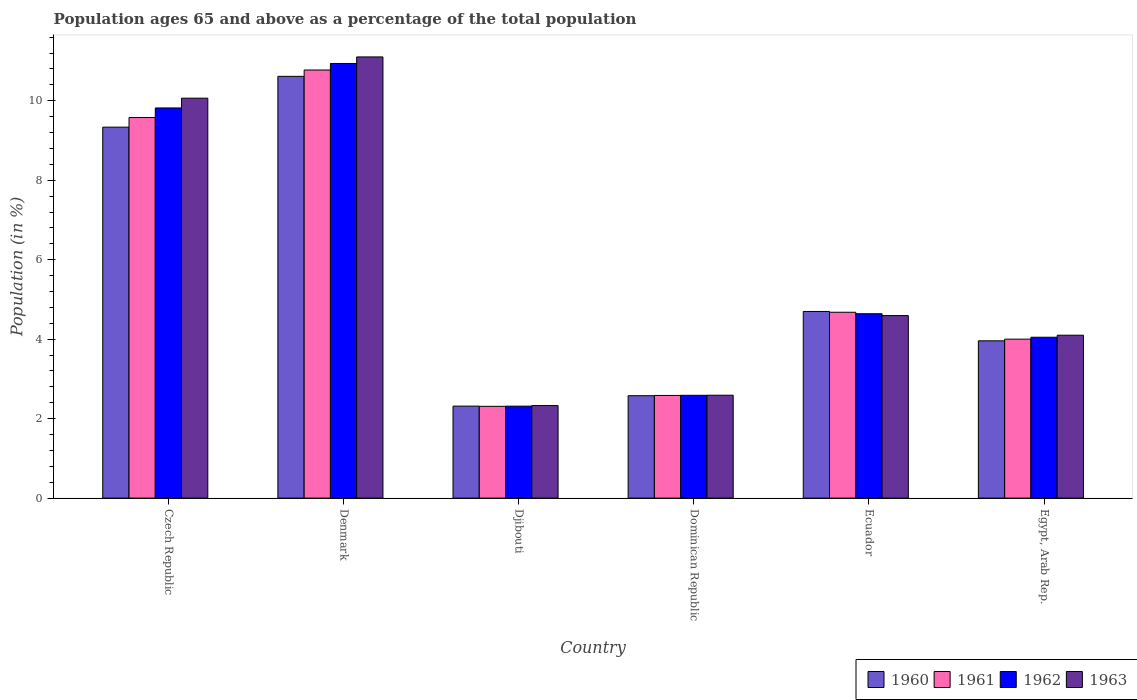Are the number of bars on each tick of the X-axis equal?
Your answer should be compact. Yes. How many bars are there on the 6th tick from the left?
Provide a succinct answer. 4. What is the label of the 5th group of bars from the left?
Provide a short and direct response. Ecuador. In how many cases, is the number of bars for a given country not equal to the number of legend labels?
Provide a short and direct response. 0. What is the percentage of the population ages 65 and above in 1963 in Egypt, Arab Rep.?
Provide a short and direct response. 4.1. Across all countries, what is the maximum percentage of the population ages 65 and above in 1963?
Give a very brief answer. 11.1. Across all countries, what is the minimum percentage of the population ages 65 and above in 1963?
Provide a succinct answer. 2.33. In which country was the percentage of the population ages 65 and above in 1963 minimum?
Offer a very short reply. Djibouti. What is the total percentage of the population ages 65 and above in 1963 in the graph?
Provide a short and direct response. 34.78. What is the difference between the percentage of the population ages 65 and above in 1961 in Denmark and that in Djibouti?
Your answer should be compact. 8.46. What is the difference between the percentage of the population ages 65 and above in 1961 in Dominican Republic and the percentage of the population ages 65 and above in 1962 in Denmark?
Your answer should be compact. -8.36. What is the average percentage of the population ages 65 and above in 1963 per country?
Your answer should be compact. 5.8. What is the difference between the percentage of the population ages 65 and above of/in 1961 and percentage of the population ages 65 and above of/in 1960 in Czech Republic?
Your answer should be very brief. 0.24. In how many countries, is the percentage of the population ages 65 and above in 1962 greater than 6?
Offer a terse response. 2. What is the ratio of the percentage of the population ages 65 and above in 1961 in Czech Republic to that in Egypt, Arab Rep.?
Ensure brevity in your answer.  2.39. Is the difference between the percentage of the population ages 65 and above in 1961 in Denmark and Egypt, Arab Rep. greater than the difference between the percentage of the population ages 65 and above in 1960 in Denmark and Egypt, Arab Rep.?
Your response must be concise. Yes. What is the difference between the highest and the second highest percentage of the population ages 65 and above in 1963?
Offer a terse response. -1.04. What is the difference between the highest and the lowest percentage of the population ages 65 and above in 1961?
Give a very brief answer. 8.46. Is the sum of the percentage of the population ages 65 and above in 1963 in Dominican Republic and Ecuador greater than the maximum percentage of the population ages 65 and above in 1962 across all countries?
Offer a terse response. No. Is it the case that in every country, the sum of the percentage of the population ages 65 and above in 1960 and percentage of the population ages 65 and above in 1963 is greater than the sum of percentage of the population ages 65 and above in 1961 and percentage of the population ages 65 and above in 1962?
Your answer should be very brief. No. Is it the case that in every country, the sum of the percentage of the population ages 65 and above in 1963 and percentage of the population ages 65 and above in 1962 is greater than the percentage of the population ages 65 and above in 1961?
Provide a short and direct response. Yes. How many bars are there?
Your answer should be very brief. 24. Are the values on the major ticks of Y-axis written in scientific E-notation?
Your response must be concise. No. Does the graph contain grids?
Offer a very short reply. No. Where does the legend appear in the graph?
Make the answer very short. Bottom right. What is the title of the graph?
Your response must be concise. Population ages 65 and above as a percentage of the total population. What is the Population (in %) of 1960 in Czech Republic?
Give a very brief answer. 9.34. What is the Population (in %) of 1961 in Czech Republic?
Provide a short and direct response. 9.58. What is the Population (in %) of 1962 in Czech Republic?
Make the answer very short. 9.82. What is the Population (in %) of 1963 in Czech Republic?
Make the answer very short. 10.07. What is the Population (in %) in 1960 in Denmark?
Ensure brevity in your answer.  10.61. What is the Population (in %) of 1961 in Denmark?
Keep it short and to the point. 10.77. What is the Population (in %) in 1962 in Denmark?
Provide a short and direct response. 10.94. What is the Population (in %) of 1963 in Denmark?
Your answer should be very brief. 11.1. What is the Population (in %) of 1960 in Djibouti?
Give a very brief answer. 2.31. What is the Population (in %) of 1961 in Djibouti?
Make the answer very short. 2.31. What is the Population (in %) of 1962 in Djibouti?
Provide a short and direct response. 2.31. What is the Population (in %) in 1963 in Djibouti?
Your response must be concise. 2.33. What is the Population (in %) of 1960 in Dominican Republic?
Offer a terse response. 2.58. What is the Population (in %) in 1961 in Dominican Republic?
Ensure brevity in your answer.  2.58. What is the Population (in %) of 1962 in Dominican Republic?
Provide a short and direct response. 2.59. What is the Population (in %) in 1963 in Dominican Republic?
Ensure brevity in your answer.  2.59. What is the Population (in %) of 1960 in Ecuador?
Provide a succinct answer. 4.7. What is the Population (in %) of 1961 in Ecuador?
Make the answer very short. 4.68. What is the Population (in %) in 1962 in Ecuador?
Keep it short and to the point. 4.64. What is the Population (in %) of 1963 in Ecuador?
Your answer should be compact. 4.59. What is the Population (in %) of 1960 in Egypt, Arab Rep.?
Offer a very short reply. 3.96. What is the Population (in %) of 1961 in Egypt, Arab Rep.?
Your response must be concise. 4. What is the Population (in %) of 1962 in Egypt, Arab Rep.?
Offer a terse response. 4.05. What is the Population (in %) in 1963 in Egypt, Arab Rep.?
Offer a very short reply. 4.1. Across all countries, what is the maximum Population (in %) in 1960?
Offer a terse response. 10.61. Across all countries, what is the maximum Population (in %) in 1961?
Your response must be concise. 10.77. Across all countries, what is the maximum Population (in %) in 1962?
Offer a terse response. 10.94. Across all countries, what is the maximum Population (in %) in 1963?
Your response must be concise. 11.1. Across all countries, what is the minimum Population (in %) of 1960?
Your answer should be very brief. 2.31. Across all countries, what is the minimum Population (in %) of 1961?
Offer a terse response. 2.31. Across all countries, what is the minimum Population (in %) in 1962?
Offer a terse response. 2.31. Across all countries, what is the minimum Population (in %) in 1963?
Give a very brief answer. 2.33. What is the total Population (in %) in 1960 in the graph?
Keep it short and to the point. 33.5. What is the total Population (in %) of 1961 in the graph?
Your response must be concise. 33.92. What is the total Population (in %) in 1962 in the graph?
Keep it short and to the point. 34.35. What is the total Population (in %) in 1963 in the graph?
Your answer should be compact. 34.78. What is the difference between the Population (in %) in 1960 in Czech Republic and that in Denmark?
Your answer should be compact. -1.28. What is the difference between the Population (in %) in 1961 in Czech Republic and that in Denmark?
Offer a terse response. -1.2. What is the difference between the Population (in %) in 1962 in Czech Republic and that in Denmark?
Keep it short and to the point. -1.12. What is the difference between the Population (in %) of 1963 in Czech Republic and that in Denmark?
Give a very brief answer. -1.04. What is the difference between the Population (in %) of 1960 in Czech Republic and that in Djibouti?
Make the answer very short. 7.02. What is the difference between the Population (in %) of 1961 in Czech Republic and that in Djibouti?
Give a very brief answer. 7.27. What is the difference between the Population (in %) in 1962 in Czech Republic and that in Djibouti?
Make the answer very short. 7.51. What is the difference between the Population (in %) of 1963 in Czech Republic and that in Djibouti?
Offer a terse response. 7.74. What is the difference between the Population (in %) of 1960 in Czech Republic and that in Dominican Republic?
Your answer should be very brief. 6.76. What is the difference between the Population (in %) in 1961 in Czech Republic and that in Dominican Republic?
Your answer should be very brief. 7. What is the difference between the Population (in %) in 1962 in Czech Republic and that in Dominican Republic?
Your answer should be compact. 7.23. What is the difference between the Population (in %) in 1963 in Czech Republic and that in Dominican Republic?
Your answer should be very brief. 7.48. What is the difference between the Population (in %) in 1960 in Czech Republic and that in Ecuador?
Give a very brief answer. 4.64. What is the difference between the Population (in %) of 1961 in Czech Republic and that in Ecuador?
Provide a short and direct response. 4.9. What is the difference between the Population (in %) in 1962 in Czech Republic and that in Ecuador?
Your response must be concise. 5.18. What is the difference between the Population (in %) in 1963 in Czech Republic and that in Ecuador?
Your answer should be compact. 5.47. What is the difference between the Population (in %) of 1960 in Czech Republic and that in Egypt, Arab Rep.?
Keep it short and to the point. 5.38. What is the difference between the Population (in %) of 1961 in Czech Republic and that in Egypt, Arab Rep.?
Provide a short and direct response. 5.58. What is the difference between the Population (in %) of 1962 in Czech Republic and that in Egypt, Arab Rep.?
Ensure brevity in your answer.  5.77. What is the difference between the Population (in %) in 1963 in Czech Republic and that in Egypt, Arab Rep.?
Your answer should be compact. 5.97. What is the difference between the Population (in %) in 1960 in Denmark and that in Djibouti?
Give a very brief answer. 8.3. What is the difference between the Population (in %) in 1961 in Denmark and that in Djibouti?
Provide a short and direct response. 8.46. What is the difference between the Population (in %) in 1962 in Denmark and that in Djibouti?
Give a very brief answer. 8.62. What is the difference between the Population (in %) of 1963 in Denmark and that in Djibouti?
Your response must be concise. 8.77. What is the difference between the Population (in %) in 1960 in Denmark and that in Dominican Republic?
Give a very brief answer. 8.04. What is the difference between the Population (in %) of 1961 in Denmark and that in Dominican Republic?
Ensure brevity in your answer.  8.19. What is the difference between the Population (in %) in 1962 in Denmark and that in Dominican Republic?
Offer a very short reply. 8.35. What is the difference between the Population (in %) in 1963 in Denmark and that in Dominican Republic?
Offer a very short reply. 8.51. What is the difference between the Population (in %) in 1960 in Denmark and that in Ecuador?
Offer a terse response. 5.92. What is the difference between the Population (in %) of 1961 in Denmark and that in Ecuador?
Your answer should be compact. 6.1. What is the difference between the Population (in %) in 1962 in Denmark and that in Ecuador?
Offer a terse response. 6.3. What is the difference between the Population (in %) in 1963 in Denmark and that in Ecuador?
Keep it short and to the point. 6.51. What is the difference between the Population (in %) of 1960 in Denmark and that in Egypt, Arab Rep.?
Make the answer very short. 6.66. What is the difference between the Population (in %) in 1961 in Denmark and that in Egypt, Arab Rep.?
Make the answer very short. 6.77. What is the difference between the Population (in %) in 1962 in Denmark and that in Egypt, Arab Rep.?
Provide a short and direct response. 6.89. What is the difference between the Population (in %) in 1963 in Denmark and that in Egypt, Arab Rep.?
Make the answer very short. 7. What is the difference between the Population (in %) of 1960 in Djibouti and that in Dominican Republic?
Your answer should be very brief. -0.26. What is the difference between the Population (in %) in 1961 in Djibouti and that in Dominican Republic?
Your answer should be very brief. -0.27. What is the difference between the Population (in %) in 1962 in Djibouti and that in Dominican Republic?
Keep it short and to the point. -0.27. What is the difference between the Population (in %) in 1963 in Djibouti and that in Dominican Republic?
Provide a short and direct response. -0.26. What is the difference between the Population (in %) of 1960 in Djibouti and that in Ecuador?
Keep it short and to the point. -2.38. What is the difference between the Population (in %) in 1961 in Djibouti and that in Ecuador?
Provide a short and direct response. -2.37. What is the difference between the Population (in %) of 1962 in Djibouti and that in Ecuador?
Provide a short and direct response. -2.33. What is the difference between the Population (in %) in 1963 in Djibouti and that in Ecuador?
Offer a very short reply. -2.26. What is the difference between the Population (in %) in 1960 in Djibouti and that in Egypt, Arab Rep.?
Your answer should be compact. -1.64. What is the difference between the Population (in %) of 1961 in Djibouti and that in Egypt, Arab Rep.?
Keep it short and to the point. -1.69. What is the difference between the Population (in %) of 1962 in Djibouti and that in Egypt, Arab Rep.?
Provide a short and direct response. -1.73. What is the difference between the Population (in %) of 1963 in Djibouti and that in Egypt, Arab Rep.?
Your response must be concise. -1.77. What is the difference between the Population (in %) in 1960 in Dominican Republic and that in Ecuador?
Offer a very short reply. -2.12. What is the difference between the Population (in %) in 1961 in Dominican Republic and that in Ecuador?
Make the answer very short. -2.09. What is the difference between the Population (in %) in 1962 in Dominican Republic and that in Ecuador?
Ensure brevity in your answer.  -2.05. What is the difference between the Population (in %) of 1963 in Dominican Republic and that in Ecuador?
Make the answer very short. -2. What is the difference between the Population (in %) of 1960 in Dominican Republic and that in Egypt, Arab Rep.?
Keep it short and to the point. -1.38. What is the difference between the Population (in %) of 1961 in Dominican Republic and that in Egypt, Arab Rep.?
Your answer should be very brief. -1.42. What is the difference between the Population (in %) in 1962 in Dominican Republic and that in Egypt, Arab Rep.?
Your answer should be very brief. -1.46. What is the difference between the Population (in %) in 1963 in Dominican Republic and that in Egypt, Arab Rep.?
Keep it short and to the point. -1.51. What is the difference between the Population (in %) in 1960 in Ecuador and that in Egypt, Arab Rep.?
Your answer should be compact. 0.74. What is the difference between the Population (in %) in 1961 in Ecuador and that in Egypt, Arab Rep.?
Give a very brief answer. 0.68. What is the difference between the Population (in %) in 1962 in Ecuador and that in Egypt, Arab Rep.?
Provide a succinct answer. 0.59. What is the difference between the Population (in %) of 1963 in Ecuador and that in Egypt, Arab Rep.?
Offer a very short reply. 0.49. What is the difference between the Population (in %) in 1960 in Czech Republic and the Population (in %) in 1961 in Denmark?
Offer a very short reply. -1.44. What is the difference between the Population (in %) of 1960 in Czech Republic and the Population (in %) of 1962 in Denmark?
Provide a succinct answer. -1.6. What is the difference between the Population (in %) in 1960 in Czech Republic and the Population (in %) in 1963 in Denmark?
Keep it short and to the point. -1.77. What is the difference between the Population (in %) of 1961 in Czech Republic and the Population (in %) of 1962 in Denmark?
Give a very brief answer. -1.36. What is the difference between the Population (in %) in 1961 in Czech Republic and the Population (in %) in 1963 in Denmark?
Give a very brief answer. -1.52. What is the difference between the Population (in %) in 1962 in Czech Republic and the Population (in %) in 1963 in Denmark?
Provide a succinct answer. -1.28. What is the difference between the Population (in %) of 1960 in Czech Republic and the Population (in %) of 1961 in Djibouti?
Provide a succinct answer. 7.03. What is the difference between the Population (in %) in 1960 in Czech Republic and the Population (in %) in 1962 in Djibouti?
Keep it short and to the point. 7.02. What is the difference between the Population (in %) in 1960 in Czech Republic and the Population (in %) in 1963 in Djibouti?
Ensure brevity in your answer.  7.01. What is the difference between the Population (in %) in 1961 in Czech Republic and the Population (in %) in 1962 in Djibouti?
Give a very brief answer. 7.26. What is the difference between the Population (in %) of 1961 in Czech Republic and the Population (in %) of 1963 in Djibouti?
Provide a succinct answer. 7.25. What is the difference between the Population (in %) in 1962 in Czech Republic and the Population (in %) in 1963 in Djibouti?
Give a very brief answer. 7.49. What is the difference between the Population (in %) in 1960 in Czech Republic and the Population (in %) in 1961 in Dominican Republic?
Offer a terse response. 6.75. What is the difference between the Population (in %) of 1960 in Czech Republic and the Population (in %) of 1962 in Dominican Republic?
Your answer should be compact. 6.75. What is the difference between the Population (in %) of 1960 in Czech Republic and the Population (in %) of 1963 in Dominican Republic?
Your answer should be compact. 6.75. What is the difference between the Population (in %) of 1961 in Czech Republic and the Population (in %) of 1962 in Dominican Republic?
Give a very brief answer. 6.99. What is the difference between the Population (in %) of 1961 in Czech Republic and the Population (in %) of 1963 in Dominican Republic?
Ensure brevity in your answer.  6.99. What is the difference between the Population (in %) in 1962 in Czech Republic and the Population (in %) in 1963 in Dominican Republic?
Provide a short and direct response. 7.23. What is the difference between the Population (in %) in 1960 in Czech Republic and the Population (in %) in 1961 in Ecuador?
Provide a succinct answer. 4.66. What is the difference between the Population (in %) of 1960 in Czech Republic and the Population (in %) of 1962 in Ecuador?
Ensure brevity in your answer.  4.7. What is the difference between the Population (in %) of 1960 in Czech Republic and the Population (in %) of 1963 in Ecuador?
Offer a terse response. 4.74. What is the difference between the Population (in %) in 1961 in Czech Republic and the Population (in %) in 1962 in Ecuador?
Ensure brevity in your answer.  4.94. What is the difference between the Population (in %) of 1961 in Czech Republic and the Population (in %) of 1963 in Ecuador?
Your answer should be very brief. 4.99. What is the difference between the Population (in %) in 1962 in Czech Republic and the Population (in %) in 1963 in Ecuador?
Make the answer very short. 5.23. What is the difference between the Population (in %) of 1960 in Czech Republic and the Population (in %) of 1961 in Egypt, Arab Rep.?
Provide a succinct answer. 5.34. What is the difference between the Population (in %) of 1960 in Czech Republic and the Population (in %) of 1962 in Egypt, Arab Rep.?
Keep it short and to the point. 5.29. What is the difference between the Population (in %) of 1960 in Czech Republic and the Population (in %) of 1963 in Egypt, Arab Rep.?
Offer a very short reply. 5.24. What is the difference between the Population (in %) in 1961 in Czech Republic and the Population (in %) in 1962 in Egypt, Arab Rep.?
Your answer should be compact. 5.53. What is the difference between the Population (in %) of 1961 in Czech Republic and the Population (in %) of 1963 in Egypt, Arab Rep.?
Ensure brevity in your answer.  5.48. What is the difference between the Population (in %) in 1962 in Czech Republic and the Population (in %) in 1963 in Egypt, Arab Rep.?
Give a very brief answer. 5.72. What is the difference between the Population (in %) in 1960 in Denmark and the Population (in %) in 1961 in Djibouti?
Offer a very short reply. 8.3. What is the difference between the Population (in %) of 1960 in Denmark and the Population (in %) of 1962 in Djibouti?
Your response must be concise. 8.3. What is the difference between the Population (in %) in 1960 in Denmark and the Population (in %) in 1963 in Djibouti?
Your response must be concise. 8.29. What is the difference between the Population (in %) of 1961 in Denmark and the Population (in %) of 1962 in Djibouti?
Your answer should be very brief. 8.46. What is the difference between the Population (in %) of 1961 in Denmark and the Population (in %) of 1963 in Djibouti?
Make the answer very short. 8.45. What is the difference between the Population (in %) of 1962 in Denmark and the Population (in %) of 1963 in Djibouti?
Make the answer very short. 8.61. What is the difference between the Population (in %) in 1960 in Denmark and the Population (in %) in 1961 in Dominican Republic?
Your response must be concise. 8.03. What is the difference between the Population (in %) in 1960 in Denmark and the Population (in %) in 1962 in Dominican Republic?
Your answer should be compact. 8.03. What is the difference between the Population (in %) in 1960 in Denmark and the Population (in %) in 1963 in Dominican Republic?
Give a very brief answer. 8.03. What is the difference between the Population (in %) in 1961 in Denmark and the Population (in %) in 1962 in Dominican Republic?
Keep it short and to the point. 8.19. What is the difference between the Population (in %) of 1961 in Denmark and the Population (in %) of 1963 in Dominican Republic?
Provide a short and direct response. 8.19. What is the difference between the Population (in %) in 1962 in Denmark and the Population (in %) in 1963 in Dominican Republic?
Make the answer very short. 8.35. What is the difference between the Population (in %) in 1960 in Denmark and the Population (in %) in 1961 in Ecuador?
Provide a short and direct response. 5.94. What is the difference between the Population (in %) of 1960 in Denmark and the Population (in %) of 1962 in Ecuador?
Your response must be concise. 5.97. What is the difference between the Population (in %) in 1960 in Denmark and the Population (in %) in 1963 in Ecuador?
Offer a terse response. 6.02. What is the difference between the Population (in %) of 1961 in Denmark and the Population (in %) of 1962 in Ecuador?
Your answer should be very brief. 6.13. What is the difference between the Population (in %) of 1961 in Denmark and the Population (in %) of 1963 in Ecuador?
Offer a very short reply. 6.18. What is the difference between the Population (in %) in 1962 in Denmark and the Population (in %) in 1963 in Ecuador?
Your answer should be very brief. 6.35. What is the difference between the Population (in %) in 1960 in Denmark and the Population (in %) in 1961 in Egypt, Arab Rep.?
Provide a succinct answer. 6.61. What is the difference between the Population (in %) of 1960 in Denmark and the Population (in %) of 1962 in Egypt, Arab Rep.?
Make the answer very short. 6.57. What is the difference between the Population (in %) in 1960 in Denmark and the Population (in %) in 1963 in Egypt, Arab Rep.?
Offer a terse response. 6.51. What is the difference between the Population (in %) of 1961 in Denmark and the Population (in %) of 1962 in Egypt, Arab Rep.?
Keep it short and to the point. 6.73. What is the difference between the Population (in %) of 1961 in Denmark and the Population (in %) of 1963 in Egypt, Arab Rep.?
Offer a very short reply. 6.67. What is the difference between the Population (in %) of 1962 in Denmark and the Population (in %) of 1963 in Egypt, Arab Rep.?
Make the answer very short. 6.84. What is the difference between the Population (in %) in 1960 in Djibouti and the Population (in %) in 1961 in Dominican Republic?
Ensure brevity in your answer.  -0.27. What is the difference between the Population (in %) of 1960 in Djibouti and the Population (in %) of 1962 in Dominican Republic?
Your answer should be compact. -0.27. What is the difference between the Population (in %) of 1960 in Djibouti and the Population (in %) of 1963 in Dominican Republic?
Your response must be concise. -0.27. What is the difference between the Population (in %) of 1961 in Djibouti and the Population (in %) of 1962 in Dominican Republic?
Provide a succinct answer. -0.28. What is the difference between the Population (in %) of 1961 in Djibouti and the Population (in %) of 1963 in Dominican Republic?
Your answer should be very brief. -0.28. What is the difference between the Population (in %) of 1962 in Djibouti and the Population (in %) of 1963 in Dominican Republic?
Ensure brevity in your answer.  -0.27. What is the difference between the Population (in %) of 1960 in Djibouti and the Population (in %) of 1961 in Ecuador?
Provide a short and direct response. -2.36. What is the difference between the Population (in %) in 1960 in Djibouti and the Population (in %) in 1962 in Ecuador?
Ensure brevity in your answer.  -2.33. What is the difference between the Population (in %) of 1960 in Djibouti and the Population (in %) of 1963 in Ecuador?
Provide a short and direct response. -2.28. What is the difference between the Population (in %) in 1961 in Djibouti and the Population (in %) in 1962 in Ecuador?
Your response must be concise. -2.33. What is the difference between the Population (in %) in 1961 in Djibouti and the Population (in %) in 1963 in Ecuador?
Provide a succinct answer. -2.28. What is the difference between the Population (in %) of 1962 in Djibouti and the Population (in %) of 1963 in Ecuador?
Give a very brief answer. -2.28. What is the difference between the Population (in %) of 1960 in Djibouti and the Population (in %) of 1961 in Egypt, Arab Rep.?
Keep it short and to the point. -1.69. What is the difference between the Population (in %) in 1960 in Djibouti and the Population (in %) in 1962 in Egypt, Arab Rep.?
Your response must be concise. -1.73. What is the difference between the Population (in %) in 1960 in Djibouti and the Population (in %) in 1963 in Egypt, Arab Rep.?
Make the answer very short. -1.78. What is the difference between the Population (in %) in 1961 in Djibouti and the Population (in %) in 1962 in Egypt, Arab Rep.?
Your answer should be very brief. -1.74. What is the difference between the Population (in %) of 1961 in Djibouti and the Population (in %) of 1963 in Egypt, Arab Rep.?
Make the answer very short. -1.79. What is the difference between the Population (in %) of 1962 in Djibouti and the Population (in %) of 1963 in Egypt, Arab Rep.?
Make the answer very short. -1.79. What is the difference between the Population (in %) in 1960 in Dominican Republic and the Population (in %) in 1961 in Ecuador?
Give a very brief answer. -2.1. What is the difference between the Population (in %) in 1960 in Dominican Republic and the Population (in %) in 1962 in Ecuador?
Make the answer very short. -2.06. What is the difference between the Population (in %) of 1960 in Dominican Republic and the Population (in %) of 1963 in Ecuador?
Make the answer very short. -2.02. What is the difference between the Population (in %) in 1961 in Dominican Republic and the Population (in %) in 1962 in Ecuador?
Your answer should be very brief. -2.06. What is the difference between the Population (in %) in 1961 in Dominican Republic and the Population (in %) in 1963 in Ecuador?
Provide a succinct answer. -2.01. What is the difference between the Population (in %) of 1962 in Dominican Republic and the Population (in %) of 1963 in Ecuador?
Your answer should be very brief. -2.01. What is the difference between the Population (in %) of 1960 in Dominican Republic and the Population (in %) of 1961 in Egypt, Arab Rep.?
Your response must be concise. -1.42. What is the difference between the Population (in %) of 1960 in Dominican Republic and the Population (in %) of 1962 in Egypt, Arab Rep.?
Your answer should be compact. -1.47. What is the difference between the Population (in %) in 1960 in Dominican Republic and the Population (in %) in 1963 in Egypt, Arab Rep.?
Make the answer very short. -1.52. What is the difference between the Population (in %) of 1961 in Dominican Republic and the Population (in %) of 1962 in Egypt, Arab Rep.?
Make the answer very short. -1.47. What is the difference between the Population (in %) in 1961 in Dominican Republic and the Population (in %) in 1963 in Egypt, Arab Rep.?
Provide a succinct answer. -1.52. What is the difference between the Population (in %) of 1962 in Dominican Republic and the Population (in %) of 1963 in Egypt, Arab Rep.?
Keep it short and to the point. -1.51. What is the difference between the Population (in %) of 1960 in Ecuador and the Population (in %) of 1961 in Egypt, Arab Rep.?
Provide a succinct answer. 0.7. What is the difference between the Population (in %) of 1960 in Ecuador and the Population (in %) of 1962 in Egypt, Arab Rep.?
Make the answer very short. 0.65. What is the difference between the Population (in %) of 1960 in Ecuador and the Population (in %) of 1963 in Egypt, Arab Rep.?
Keep it short and to the point. 0.6. What is the difference between the Population (in %) of 1961 in Ecuador and the Population (in %) of 1962 in Egypt, Arab Rep.?
Provide a short and direct response. 0.63. What is the difference between the Population (in %) of 1961 in Ecuador and the Population (in %) of 1963 in Egypt, Arab Rep.?
Ensure brevity in your answer.  0.58. What is the difference between the Population (in %) in 1962 in Ecuador and the Population (in %) in 1963 in Egypt, Arab Rep.?
Your response must be concise. 0.54. What is the average Population (in %) of 1960 per country?
Your answer should be very brief. 5.58. What is the average Population (in %) of 1961 per country?
Your answer should be compact. 5.65. What is the average Population (in %) of 1962 per country?
Your answer should be very brief. 5.72. What is the average Population (in %) in 1963 per country?
Give a very brief answer. 5.8. What is the difference between the Population (in %) of 1960 and Population (in %) of 1961 in Czech Republic?
Give a very brief answer. -0.24. What is the difference between the Population (in %) in 1960 and Population (in %) in 1962 in Czech Republic?
Your answer should be compact. -0.48. What is the difference between the Population (in %) of 1960 and Population (in %) of 1963 in Czech Republic?
Provide a short and direct response. -0.73. What is the difference between the Population (in %) of 1961 and Population (in %) of 1962 in Czech Republic?
Offer a very short reply. -0.24. What is the difference between the Population (in %) of 1961 and Population (in %) of 1963 in Czech Republic?
Make the answer very short. -0.49. What is the difference between the Population (in %) in 1962 and Population (in %) in 1963 in Czech Republic?
Ensure brevity in your answer.  -0.25. What is the difference between the Population (in %) in 1960 and Population (in %) in 1961 in Denmark?
Provide a short and direct response. -0.16. What is the difference between the Population (in %) of 1960 and Population (in %) of 1962 in Denmark?
Keep it short and to the point. -0.32. What is the difference between the Population (in %) in 1960 and Population (in %) in 1963 in Denmark?
Keep it short and to the point. -0.49. What is the difference between the Population (in %) in 1961 and Population (in %) in 1962 in Denmark?
Your response must be concise. -0.16. What is the difference between the Population (in %) in 1961 and Population (in %) in 1963 in Denmark?
Give a very brief answer. -0.33. What is the difference between the Population (in %) in 1962 and Population (in %) in 1963 in Denmark?
Provide a succinct answer. -0.16. What is the difference between the Population (in %) of 1960 and Population (in %) of 1961 in Djibouti?
Provide a short and direct response. 0.01. What is the difference between the Population (in %) of 1960 and Population (in %) of 1962 in Djibouti?
Keep it short and to the point. 0. What is the difference between the Population (in %) of 1960 and Population (in %) of 1963 in Djibouti?
Ensure brevity in your answer.  -0.01. What is the difference between the Population (in %) in 1961 and Population (in %) in 1962 in Djibouti?
Ensure brevity in your answer.  -0. What is the difference between the Population (in %) in 1961 and Population (in %) in 1963 in Djibouti?
Provide a succinct answer. -0.02. What is the difference between the Population (in %) of 1962 and Population (in %) of 1963 in Djibouti?
Your answer should be compact. -0.01. What is the difference between the Population (in %) of 1960 and Population (in %) of 1961 in Dominican Republic?
Offer a terse response. -0.01. What is the difference between the Population (in %) of 1960 and Population (in %) of 1962 in Dominican Republic?
Your answer should be very brief. -0.01. What is the difference between the Population (in %) of 1960 and Population (in %) of 1963 in Dominican Republic?
Your answer should be compact. -0.01. What is the difference between the Population (in %) of 1961 and Population (in %) of 1962 in Dominican Republic?
Give a very brief answer. -0. What is the difference between the Population (in %) of 1961 and Population (in %) of 1963 in Dominican Republic?
Your response must be concise. -0.01. What is the difference between the Population (in %) of 1962 and Population (in %) of 1963 in Dominican Republic?
Give a very brief answer. -0. What is the difference between the Population (in %) of 1960 and Population (in %) of 1961 in Ecuador?
Your answer should be very brief. 0.02. What is the difference between the Population (in %) in 1960 and Population (in %) in 1962 in Ecuador?
Keep it short and to the point. 0.06. What is the difference between the Population (in %) of 1960 and Population (in %) of 1963 in Ecuador?
Your answer should be compact. 0.1. What is the difference between the Population (in %) of 1961 and Population (in %) of 1962 in Ecuador?
Offer a terse response. 0.04. What is the difference between the Population (in %) of 1961 and Population (in %) of 1963 in Ecuador?
Offer a terse response. 0.08. What is the difference between the Population (in %) of 1962 and Population (in %) of 1963 in Ecuador?
Give a very brief answer. 0.05. What is the difference between the Population (in %) of 1960 and Population (in %) of 1961 in Egypt, Arab Rep.?
Give a very brief answer. -0.04. What is the difference between the Population (in %) of 1960 and Population (in %) of 1962 in Egypt, Arab Rep.?
Offer a terse response. -0.09. What is the difference between the Population (in %) in 1960 and Population (in %) in 1963 in Egypt, Arab Rep.?
Your response must be concise. -0.14. What is the difference between the Population (in %) in 1961 and Population (in %) in 1962 in Egypt, Arab Rep.?
Provide a short and direct response. -0.05. What is the difference between the Population (in %) of 1961 and Population (in %) of 1963 in Egypt, Arab Rep.?
Offer a very short reply. -0.1. What is the difference between the Population (in %) in 1962 and Population (in %) in 1963 in Egypt, Arab Rep.?
Provide a succinct answer. -0.05. What is the ratio of the Population (in %) of 1960 in Czech Republic to that in Denmark?
Keep it short and to the point. 0.88. What is the ratio of the Population (in %) of 1961 in Czech Republic to that in Denmark?
Your answer should be very brief. 0.89. What is the ratio of the Population (in %) in 1962 in Czech Republic to that in Denmark?
Ensure brevity in your answer.  0.9. What is the ratio of the Population (in %) of 1963 in Czech Republic to that in Denmark?
Provide a succinct answer. 0.91. What is the ratio of the Population (in %) of 1960 in Czech Republic to that in Djibouti?
Offer a terse response. 4.03. What is the ratio of the Population (in %) in 1961 in Czech Republic to that in Djibouti?
Your answer should be very brief. 4.15. What is the ratio of the Population (in %) of 1962 in Czech Republic to that in Djibouti?
Keep it short and to the point. 4.24. What is the ratio of the Population (in %) of 1963 in Czech Republic to that in Djibouti?
Give a very brief answer. 4.32. What is the ratio of the Population (in %) in 1960 in Czech Republic to that in Dominican Republic?
Keep it short and to the point. 3.62. What is the ratio of the Population (in %) in 1961 in Czech Republic to that in Dominican Republic?
Your response must be concise. 3.71. What is the ratio of the Population (in %) in 1962 in Czech Republic to that in Dominican Republic?
Provide a succinct answer. 3.8. What is the ratio of the Population (in %) of 1963 in Czech Republic to that in Dominican Republic?
Give a very brief answer. 3.89. What is the ratio of the Population (in %) of 1960 in Czech Republic to that in Ecuador?
Offer a terse response. 1.99. What is the ratio of the Population (in %) of 1961 in Czech Republic to that in Ecuador?
Offer a very short reply. 2.05. What is the ratio of the Population (in %) in 1962 in Czech Republic to that in Ecuador?
Offer a very short reply. 2.12. What is the ratio of the Population (in %) in 1963 in Czech Republic to that in Ecuador?
Offer a terse response. 2.19. What is the ratio of the Population (in %) in 1960 in Czech Republic to that in Egypt, Arab Rep.?
Your answer should be compact. 2.36. What is the ratio of the Population (in %) in 1961 in Czech Republic to that in Egypt, Arab Rep.?
Ensure brevity in your answer.  2.39. What is the ratio of the Population (in %) of 1962 in Czech Republic to that in Egypt, Arab Rep.?
Your answer should be compact. 2.43. What is the ratio of the Population (in %) in 1963 in Czech Republic to that in Egypt, Arab Rep.?
Your answer should be very brief. 2.46. What is the ratio of the Population (in %) of 1960 in Denmark to that in Djibouti?
Offer a terse response. 4.59. What is the ratio of the Population (in %) of 1961 in Denmark to that in Djibouti?
Offer a terse response. 4.67. What is the ratio of the Population (in %) in 1962 in Denmark to that in Djibouti?
Offer a very short reply. 4.73. What is the ratio of the Population (in %) in 1963 in Denmark to that in Djibouti?
Your response must be concise. 4.77. What is the ratio of the Population (in %) in 1960 in Denmark to that in Dominican Republic?
Your answer should be very brief. 4.12. What is the ratio of the Population (in %) in 1961 in Denmark to that in Dominican Republic?
Provide a short and direct response. 4.17. What is the ratio of the Population (in %) of 1962 in Denmark to that in Dominican Republic?
Keep it short and to the point. 4.23. What is the ratio of the Population (in %) in 1963 in Denmark to that in Dominican Republic?
Your answer should be compact. 4.29. What is the ratio of the Population (in %) of 1960 in Denmark to that in Ecuador?
Your answer should be compact. 2.26. What is the ratio of the Population (in %) of 1961 in Denmark to that in Ecuador?
Your answer should be compact. 2.3. What is the ratio of the Population (in %) in 1962 in Denmark to that in Ecuador?
Give a very brief answer. 2.36. What is the ratio of the Population (in %) of 1963 in Denmark to that in Ecuador?
Offer a terse response. 2.42. What is the ratio of the Population (in %) of 1960 in Denmark to that in Egypt, Arab Rep.?
Your response must be concise. 2.68. What is the ratio of the Population (in %) in 1961 in Denmark to that in Egypt, Arab Rep.?
Keep it short and to the point. 2.69. What is the ratio of the Population (in %) of 1962 in Denmark to that in Egypt, Arab Rep.?
Offer a very short reply. 2.7. What is the ratio of the Population (in %) of 1963 in Denmark to that in Egypt, Arab Rep.?
Make the answer very short. 2.71. What is the ratio of the Population (in %) of 1960 in Djibouti to that in Dominican Republic?
Provide a succinct answer. 0.9. What is the ratio of the Population (in %) in 1961 in Djibouti to that in Dominican Republic?
Your response must be concise. 0.89. What is the ratio of the Population (in %) in 1962 in Djibouti to that in Dominican Republic?
Your answer should be compact. 0.89. What is the ratio of the Population (in %) in 1963 in Djibouti to that in Dominican Republic?
Ensure brevity in your answer.  0.9. What is the ratio of the Population (in %) of 1960 in Djibouti to that in Ecuador?
Your response must be concise. 0.49. What is the ratio of the Population (in %) in 1961 in Djibouti to that in Ecuador?
Your answer should be very brief. 0.49. What is the ratio of the Population (in %) in 1962 in Djibouti to that in Ecuador?
Offer a terse response. 0.5. What is the ratio of the Population (in %) in 1963 in Djibouti to that in Ecuador?
Your response must be concise. 0.51. What is the ratio of the Population (in %) of 1960 in Djibouti to that in Egypt, Arab Rep.?
Your response must be concise. 0.58. What is the ratio of the Population (in %) in 1961 in Djibouti to that in Egypt, Arab Rep.?
Your answer should be very brief. 0.58. What is the ratio of the Population (in %) in 1962 in Djibouti to that in Egypt, Arab Rep.?
Offer a terse response. 0.57. What is the ratio of the Population (in %) in 1963 in Djibouti to that in Egypt, Arab Rep.?
Provide a short and direct response. 0.57. What is the ratio of the Population (in %) of 1960 in Dominican Republic to that in Ecuador?
Offer a very short reply. 0.55. What is the ratio of the Population (in %) of 1961 in Dominican Republic to that in Ecuador?
Give a very brief answer. 0.55. What is the ratio of the Population (in %) of 1962 in Dominican Republic to that in Ecuador?
Give a very brief answer. 0.56. What is the ratio of the Population (in %) in 1963 in Dominican Republic to that in Ecuador?
Provide a succinct answer. 0.56. What is the ratio of the Population (in %) in 1960 in Dominican Republic to that in Egypt, Arab Rep.?
Provide a short and direct response. 0.65. What is the ratio of the Population (in %) of 1961 in Dominican Republic to that in Egypt, Arab Rep.?
Offer a terse response. 0.65. What is the ratio of the Population (in %) of 1962 in Dominican Republic to that in Egypt, Arab Rep.?
Offer a terse response. 0.64. What is the ratio of the Population (in %) of 1963 in Dominican Republic to that in Egypt, Arab Rep.?
Your answer should be compact. 0.63. What is the ratio of the Population (in %) of 1960 in Ecuador to that in Egypt, Arab Rep.?
Ensure brevity in your answer.  1.19. What is the ratio of the Population (in %) in 1961 in Ecuador to that in Egypt, Arab Rep.?
Provide a succinct answer. 1.17. What is the ratio of the Population (in %) of 1962 in Ecuador to that in Egypt, Arab Rep.?
Offer a terse response. 1.15. What is the ratio of the Population (in %) of 1963 in Ecuador to that in Egypt, Arab Rep.?
Your answer should be very brief. 1.12. What is the difference between the highest and the second highest Population (in %) in 1960?
Your answer should be very brief. 1.28. What is the difference between the highest and the second highest Population (in %) of 1961?
Offer a terse response. 1.2. What is the difference between the highest and the second highest Population (in %) of 1962?
Provide a short and direct response. 1.12. What is the difference between the highest and the second highest Population (in %) of 1963?
Your answer should be compact. 1.04. What is the difference between the highest and the lowest Population (in %) of 1960?
Offer a very short reply. 8.3. What is the difference between the highest and the lowest Population (in %) of 1961?
Ensure brevity in your answer.  8.46. What is the difference between the highest and the lowest Population (in %) of 1962?
Your response must be concise. 8.62. What is the difference between the highest and the lowest Population (in %) in 1963?
Provide a short and direct response. 8.77. 